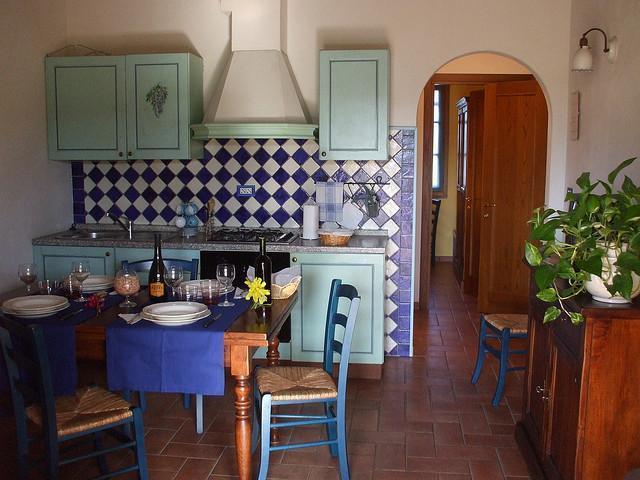How many chairs can you see?
Give a very brief answer. 3. How many people are walking on the crosswalk?
Give a very brief answer. 0. 